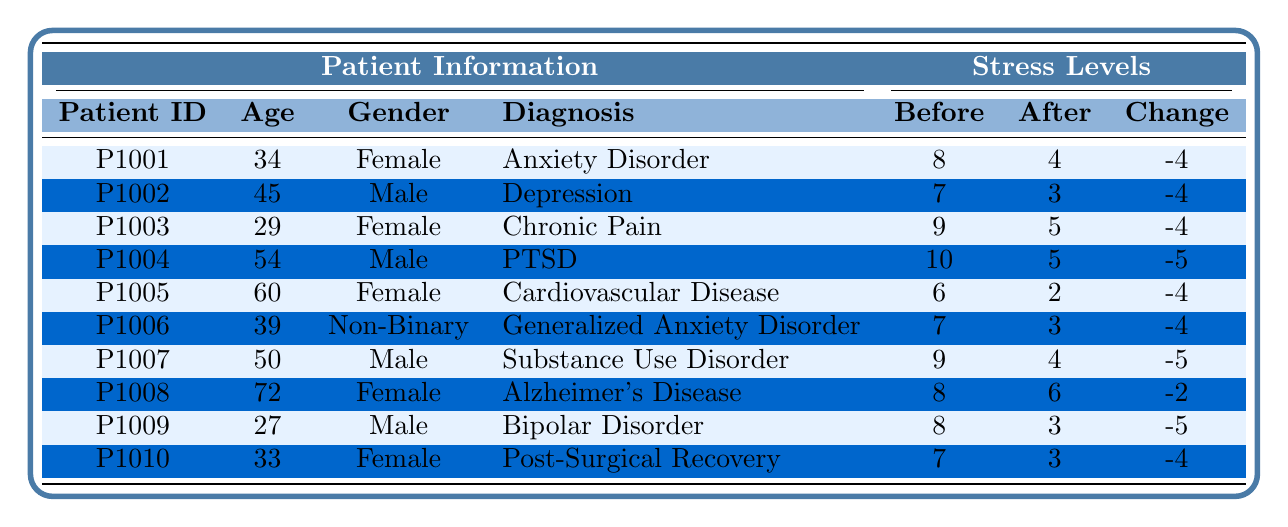What was the highest stress level recorded before meditation among the patients? Looking at the "Before Meditation" column, the highest value is 10, which corresponds to Patient ID P1004, who has a diagnosis of PTSD.
Answer: 10 How many patients experienced a change in stress level of -5? By examining the "Change in Stress Level" column, we see that the values -5 occur for three patients: P1004, P1007, and P1009. Thus, there are three patients with this change.
Answer: 3 What is the average stress level before meditation for all patients? To calculate the average, I sum all the "Before Meditation" values: 8 + 7 + 9 + 10 + 6 + 7 + 9 + 8 + 8 + 7 = 79. There are 10 patients, so the average is 79/10 = 7.9.
Answer: 7.9 Is it true that all patients improved their stress levels after meditation? By checking the "Change in Stress Level" column, I see that not all patients improved; Patient ID P1008 had a change of -2, indicating some reduction, but it’s not as significant. Therefore, it’s not strictly true that all improved.
Answer: No Which gender had more patients with a change in stress level of -4? From the data, we see that the patients with a change of -4 are predominantly Female (P1001, P1003, P1005, P1010; total 4) while there is only one male (P1002, P1006) with this change.
Answer: Female What was the most significant improvement in stress levels after meditation, and which patient achieved it? The most significant improvement is by Patient ID P1004, who experienced a change of -5 (from 10 to 5). This is the biggest decrease recorded.
Answer: P1004 What is the median age of the patients who had a stress level change of -4? The patients with a -4 change are aged 34, 45, 29, 60, 39, and 33. Arranging these ages gives: 29, 33, 34, 39, 45, 60. With an even number of patients, the median is the average of the two middle values (34 and 39), resulting in (34 + 39)/2 = 36.5.
Answer: 36.5 How many patients over the age of 50 reported a change in stress level of -4 or less? Only Patient P1005 (age 60) reported a change of -4, and P1004 and P1007 (both over 50) reported -5 changes. So there are 3 patients (P1004, P1005, and P1007) reporting changes of -4 or less.
Answer: 3 What percentage of patients had a stress level of more than 8 before meditation? There are 4 patients with a "Before Meditation" score of more than 8 (P1003, P1004, P1007, P1009). Thus, (4/10) * 100% = 40%.
Answer: 40% Is there any patient with a lesser stress level after meditation than before? Yes, by checking the "After Meditation" column, I identify patients like P1004 (Before: 10, After: 5) and P1007 (Before: 9, After: 4). Both have lower stress levels after meditation.
Answer: Yes 